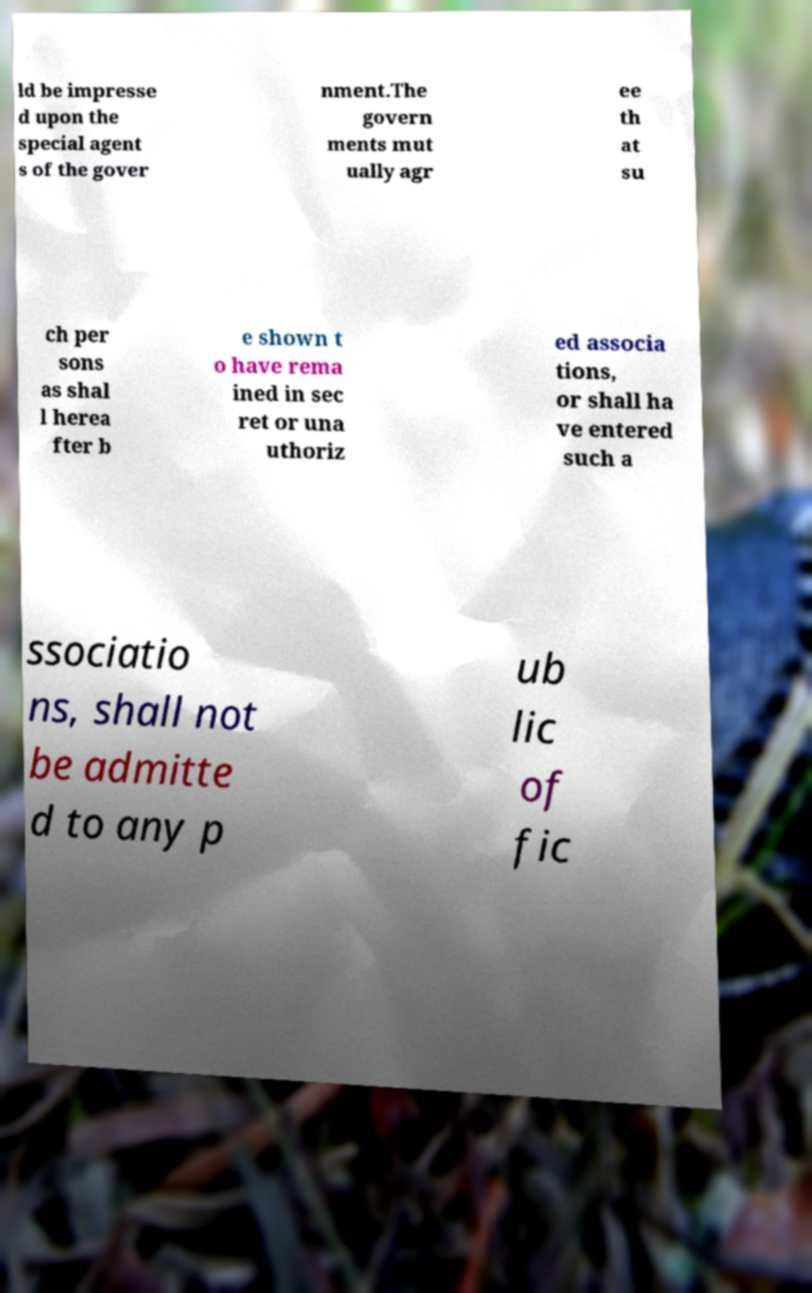What messages or text are displayed in this image? I need them in a readable, typed format. ld be impresse d upon the special agent s of the gover nment.The govern ments mut ually agr ee th at su ch per sons as shal l herea fter b e shown t o have rema ined in sec ret or una uthoriz ed associa tions, or shall ha ve entered such a ssociatio ns, shall not be admitte d to any p ub lic of fic 